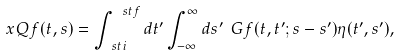<formula> <loc_0><loc_0><loc_500><loc_500>\ x Q f ( t , s ) = \int ^ { \ s t f } _ { \ s t i } d t ^ { \prime } \int ^ { \infty } _ { - \infty } d s ^ { \prime } \ G f ( t , t ^ { \prime } ; s - s ^ { \prime } ) \eta ( t ^ { \prime } , s ^ { \prime } ) ,</formula> 